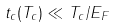<formula> <loc_0><loc_0><loc_500><loc_500>t _ { c } ( T _ { c } ) \ll T _ { c } / E _ { F }</formula> 